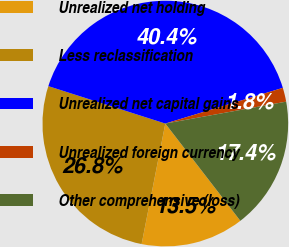<chart> <loc_0><loc_0><loc_500><loc_500><pie_chart><fcel>Unrealized net holding<fcel>Less reclassification<fcel>Unrealized net capital gains<fcel>Unrealized foreign currency<fcel>Other comprehensive (loss)<nl><fcel>13.55%<fcel>26.84%<fcel>40.38%<fcel>1.84%<fcel>17.4%<nl></chart> 